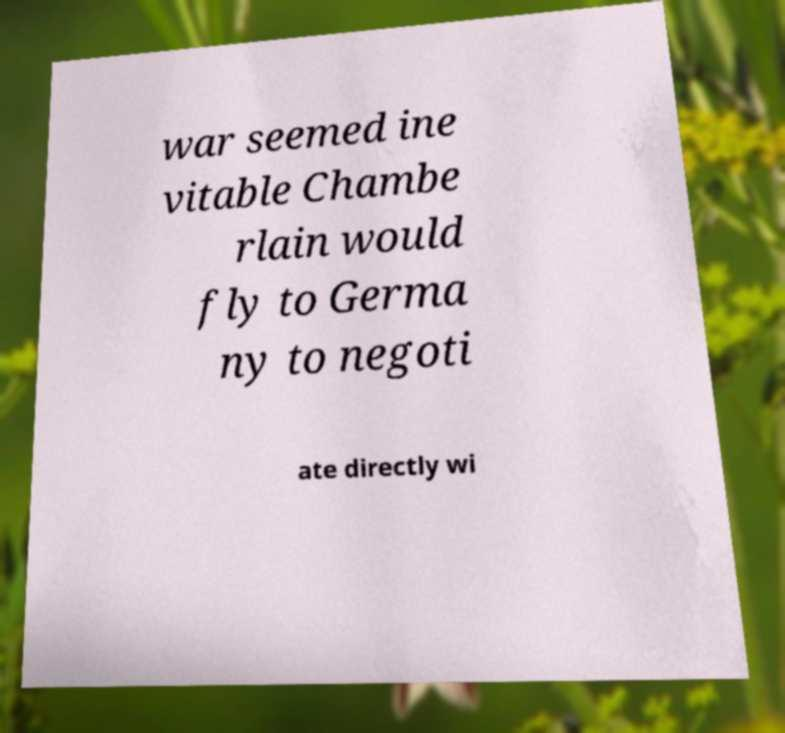Could you assist in decoding the text presented in this image and type it out clearly? war seemed ine vitable Chambe rlain would fly to Germa ny to negoti ate directly wi 